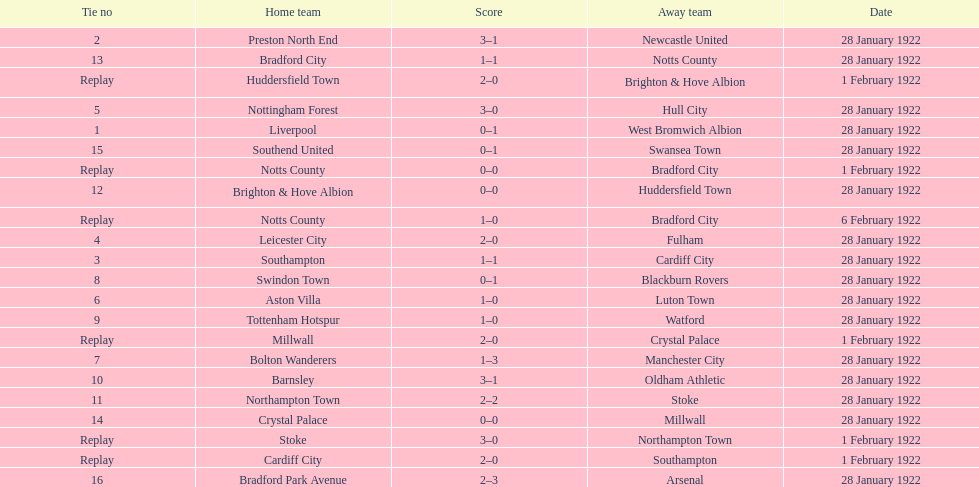How many games had no points scored? 3. 